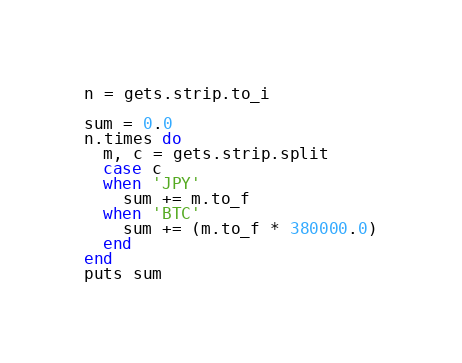Convert code to text. <code><loc_0><loc_0><loc_500><loc_500><_Ruby_>n = gets.strip.to_i

sum = 0.0 
n.times do 
  m, c = gets.strip.split
  case c
  when 'JPY'
    sum += m.to_f
  when 'BTC'
    sum += (m.to_f * 380000.0)
  end
end
puts sum
</code> 